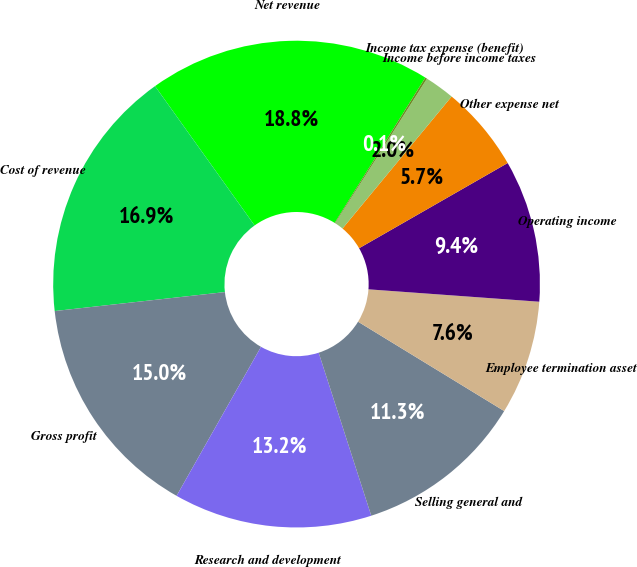Convert chart to OTSL. <chart><loc_0><loc_0><loc_500><loc_500><pie_chart><fcel>Net revenue<fcel>Cost of revenue<fcel>Gross profit<fcel>Research and development<fcel>Selling general and<fcel>Employee termination asset<fcel>Operating income<fcel>Other expense net<fcel>Income before income taxes<fcel>Income tax expense (benefit)<nl><fcel>18.75%<fcel>16.89%<fcel>15.03%<fcel>13.17%<fcel>11.3%<fcel>7.58%<fcel>9.44%<fcel>5.72%<fcel>1.99%<fcel>0.13%<nl></chart> 